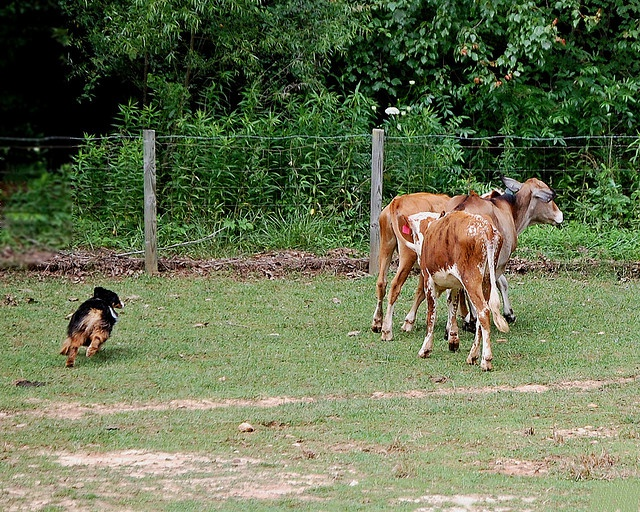Describe the objects in this image and their specific colors. I can see cow in black, tan, darkgray, and gray tones, cow in black, salmon, lightgray, brown, and maroon tones, and dog in black, gray, maroon, and tan tones in this image. 